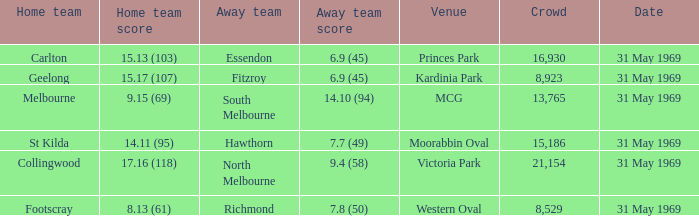In the game where the home team scored 15.17 (107), who was the away team? Fitzroy. 